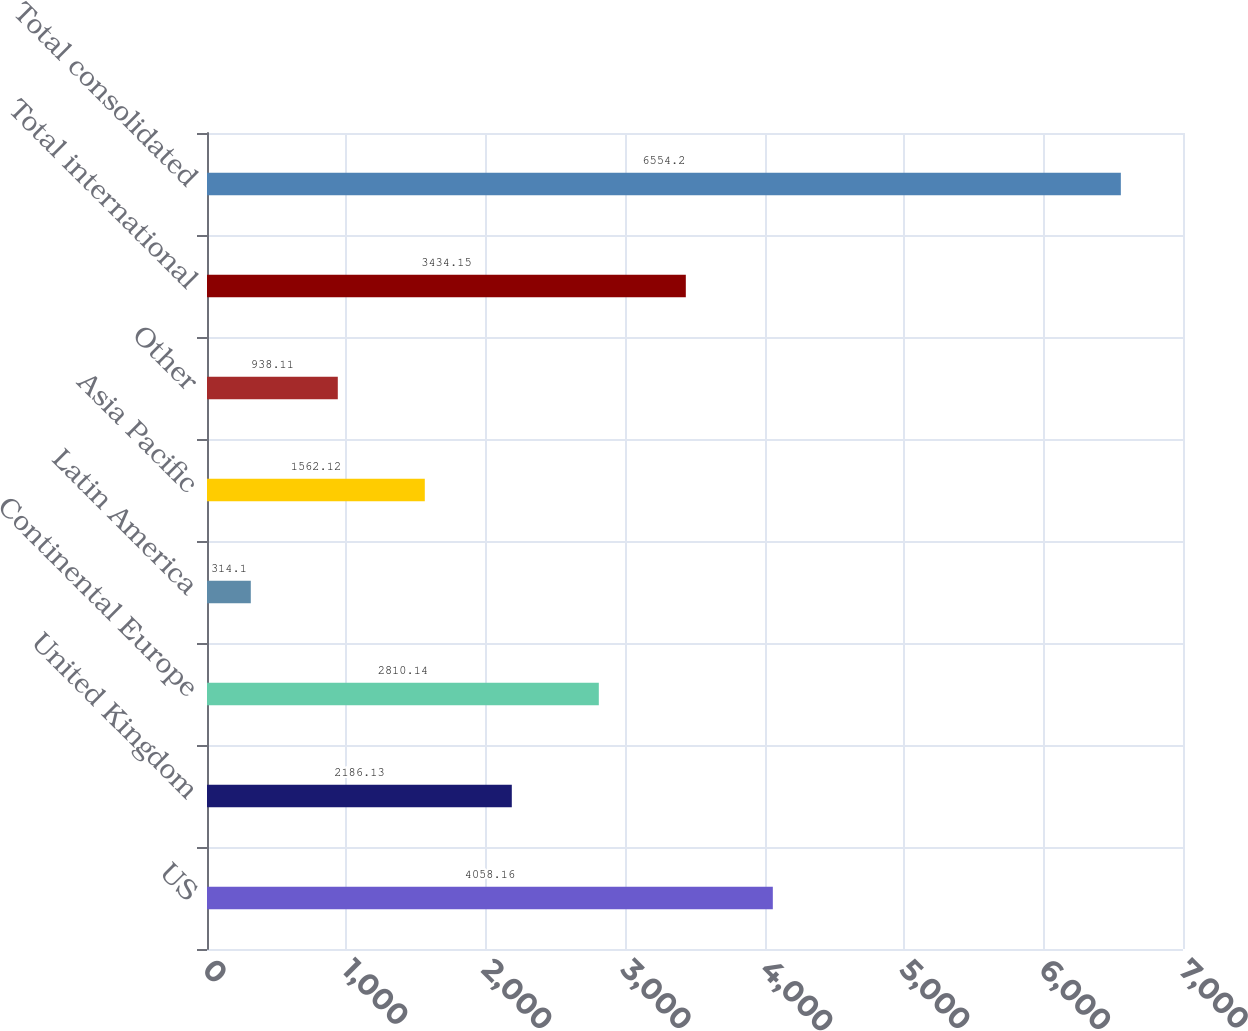Convert chart. <chart><loc_0><loc_0><loc_500><loc_500><bar_chart><fcel>US<fcel>United Kingdom<fcel>Continental Europe<fcel>Latin America<fcel>Asia Pacific<fcel>Other<fcel>Total international<fcel>Total consolidated<nl><fcel>4058.16<fcel>2186.13<fcel>2810.14<fcel>314.1<fcel>1562.12<fcel>938.11<fcel>3434.15<fcel>6554.2<nl></chart> 